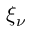Convert formula to latex. <formula><loc_0><loc_0><loc_500><loc_500>\xi _ { \nu }</formula> 